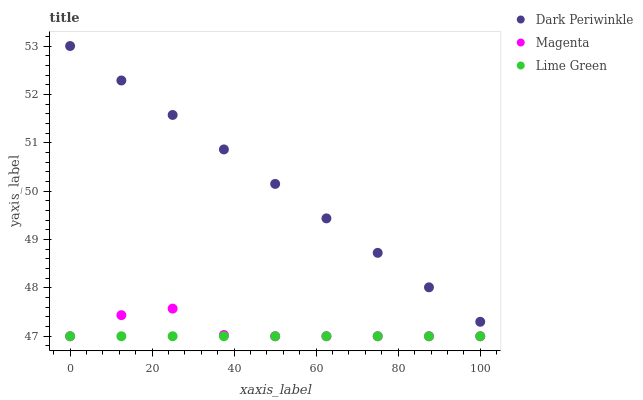Does Lime Green have the minimum area under the curve?
Answer yes or no. Yes. Does Dark Periwinkle have the maximum area under the curve?
Answer yes or no. Yes. Does Dark Periwinkle have the minimum area under the curve?
Answer yes or no. No. Does Lime Green have the maximum area under the curve?
Answer yes or no. No. Is Lime Green the smoothest?
Answer yes or no. Yes. Is Magenta the roughest?
Answer yes or no. Yes. Is Dark Periwinkle the smoothest?
Answer yes or no. No. Is Dark Periwinkle the roughest?
Answer yes or no. No. Does Magenta have the lowest value?
Answer yes or no. Yes. Does Dark Periwinkle have the lowest value?
Answer yes or no. No. Does Dark Periwinkle have the highest value?
Answer yes or no. Yes. Does Lime Green have the highest value?
Answer yes or no. No. Is Magenta less than Dark Periwinkle?
Answer yes or no. Yes. Is Dark Periwinkle greater than Magenta?
Answer yes or no. Yes. Does Lime Green intersect Magenta?
Answer yes or no. Yes. Is Lime Green less than Magenta?
Answer yes or no. No. Is Lime Green greater than Magenta?
Answer yes or no. No. Does Magenta intersect Dark Periwinkle?
Answer yes or no. No. 